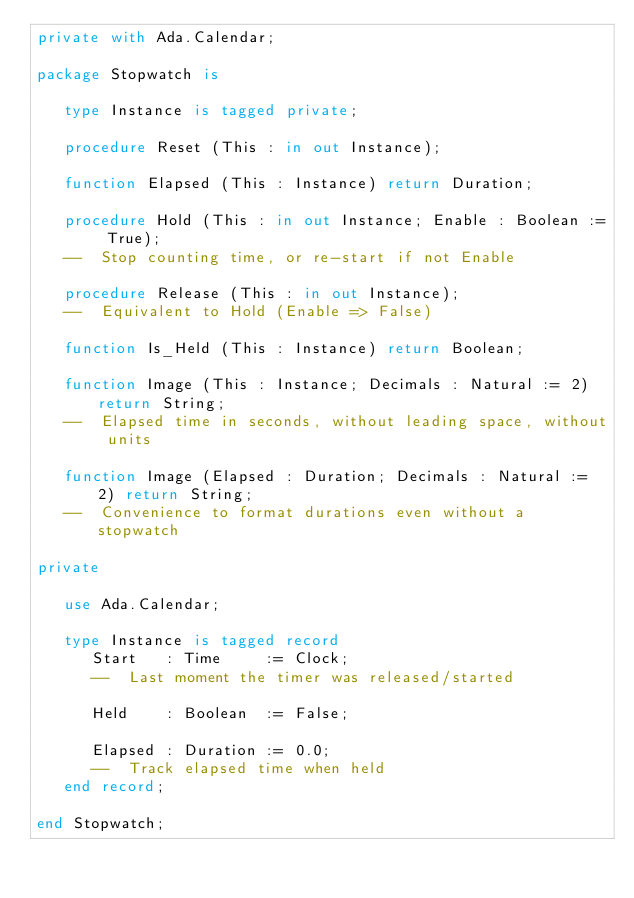Convert code to text. <code><loc_0><loc_0><loc_500><loc_500><_Ada_>private with Ada.Calendar;

package Stopwatch is

   type Instance is tagged private;

   procedure Reset (This : in out Instance);

   function Elapsed (This : Instance) return Duration;

   procedure Hold (This : in out Instance; Enable : Boolean := True);
   --  Stop counting time, or re-start if not Enable

   procedure Release (This : in out Instance);
   --  Equivalent to Hold (Enable => False)

   function Is_Held (This : Instance) return Boolean;

   function Image (This : Instance; Decimals : Natural := 2) return String;
   --  Elapsed time in seconds, without leading space, without units

   function Image (Elapsed : Duration; Decimals : Natural := 2) return String;
   --  Convenience to format durations even without a stopwatch

private

   use Ada.Calendar;

   type Instance is tagged record
      Start   : Time     := Clock;
      --  Last moment the timer was released/started

      Held    : Boolean  := False;

      Elapsed : Duration := 0.0;
      --  Track elapsed time when held
   end record;

end Stopwatch;
</code> 